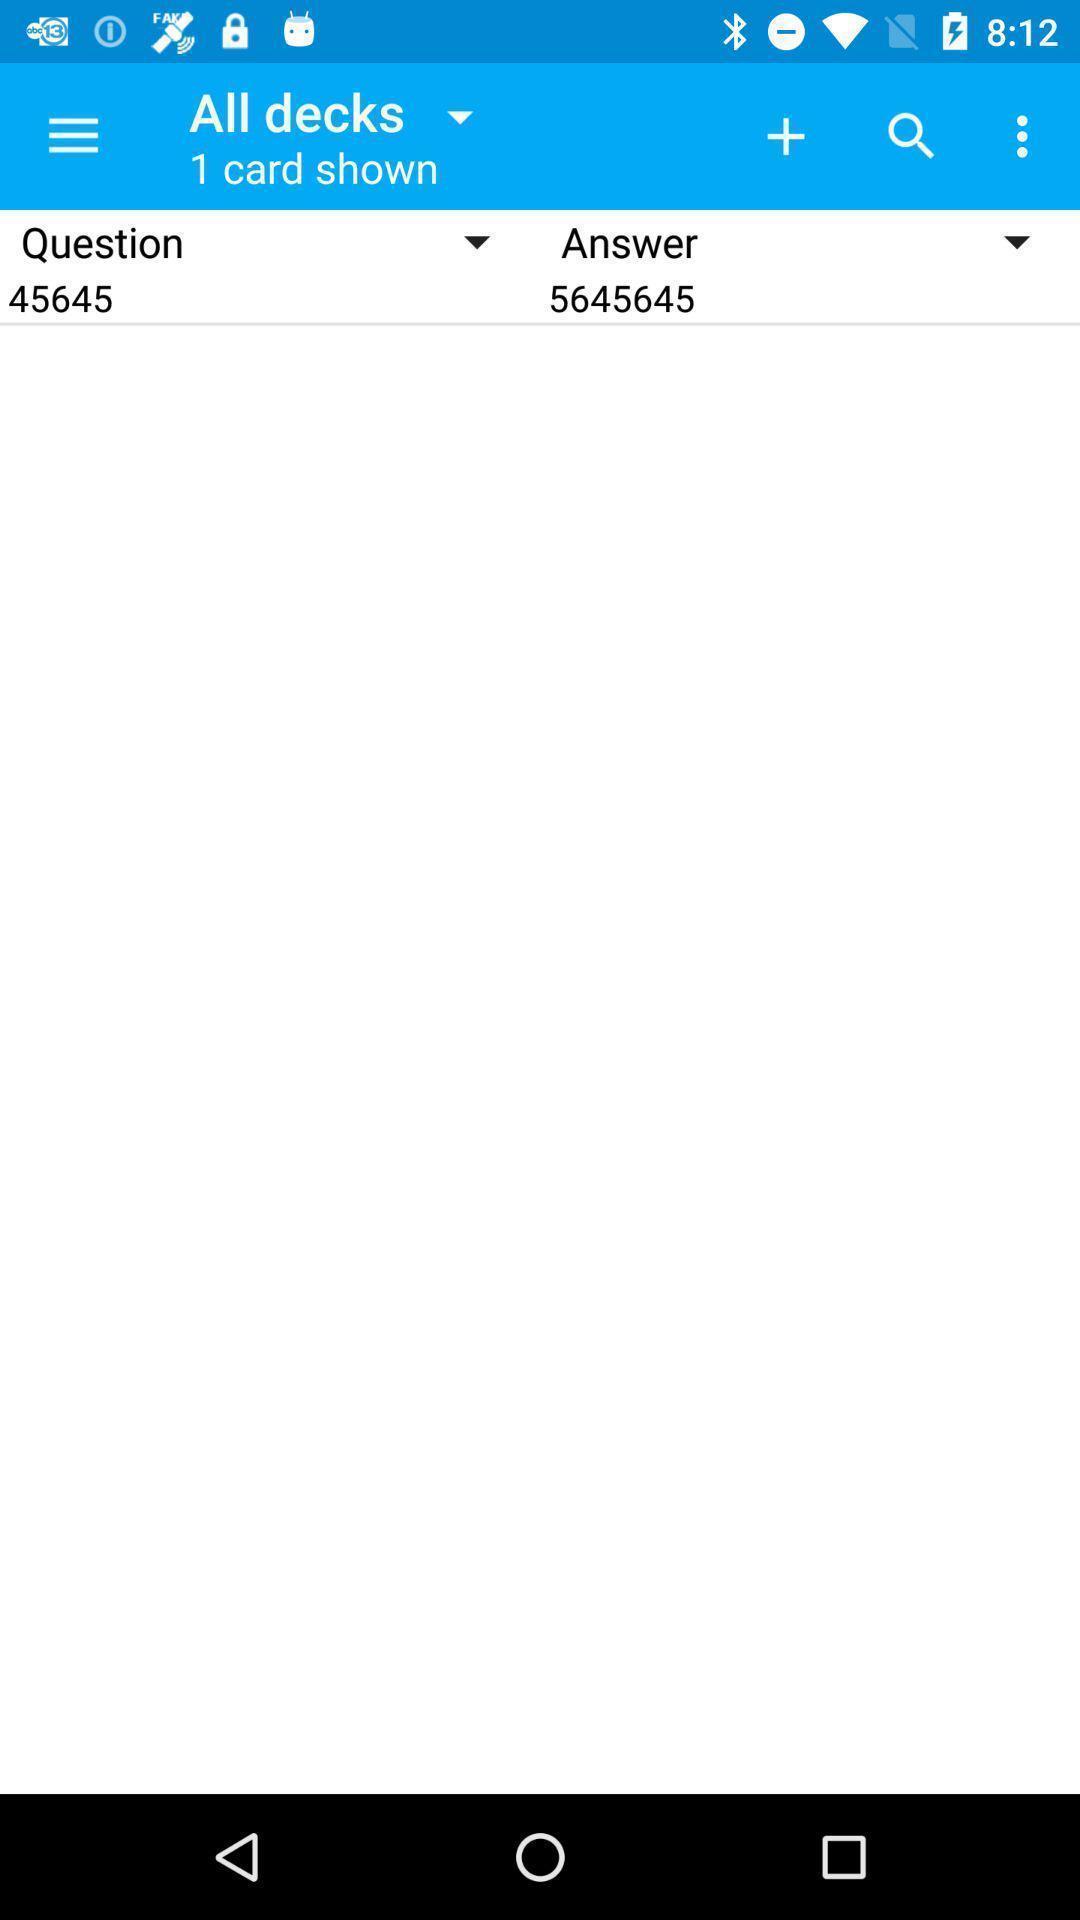Tell me what you see in this picture. Page shwing question answer. 